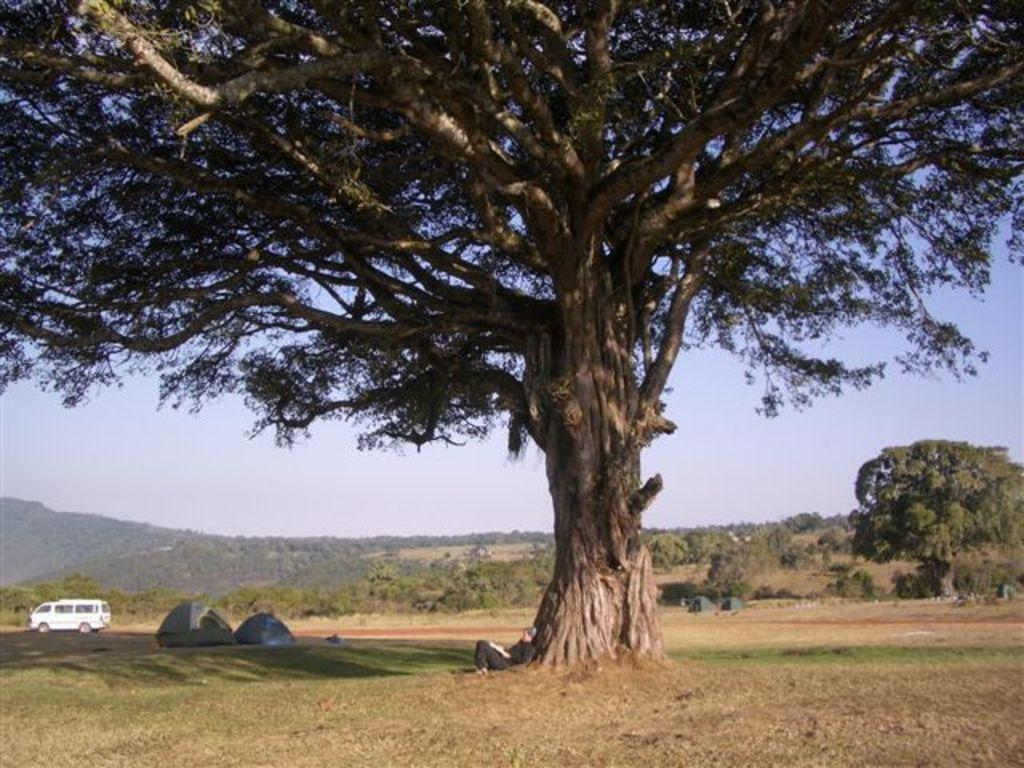What type of natural vegetation can be seen in the image? There are trees in the image. What type of structures are present in the image? There are huts in the image. What is on the ground in the image? There is a car on the ground in the image. What can be seen in the background of the image? The sky and mountains are visible in the background of the image. When was the image taken? The image was taken during the day. Where is the baby wearing underwear in the image? There is no baby or underwear present in the image. What is the head of the mountain doing in the image? There is no head of a mountain present in the image; it is a full mountain range. 